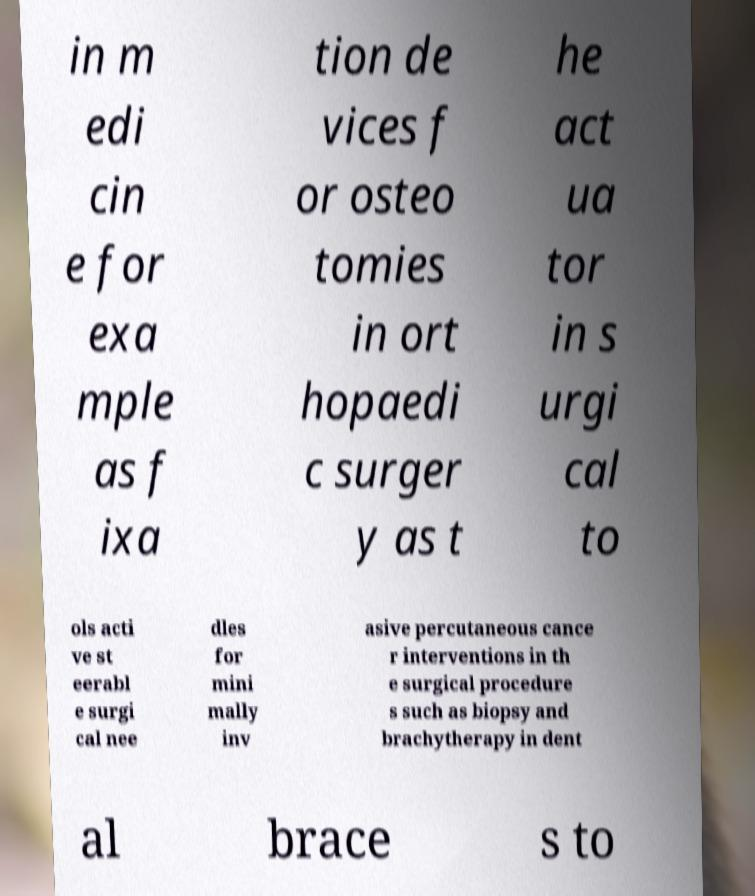Please read and relay the text visible in this image. What does it say? in m edi cin e for exa mple as f ixa tion de vices f or osteo tomies in ort hopaedi c surger y as t he act ua tor in s urgi cal to ols acti ve st eerabl e surgi cal nee dles for mini mally inv asive percutaneous cance r interventions in th e surgical procedure s such as biopsy and brachytherapy in dent al brace s to 